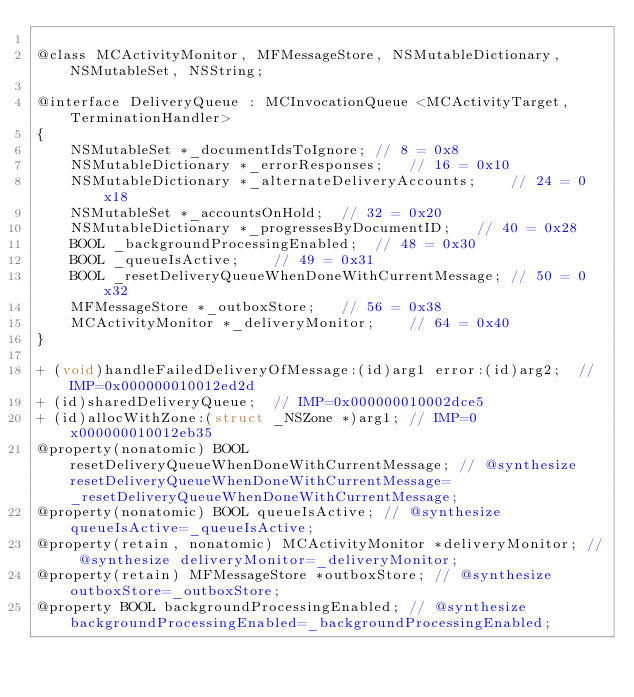Convert code to text. <code><loc_0><loc_0><loc_500><loc_500><_C_>
@class MCActivityMonitor, MFMessageStore, NSMutableDictionary, NSMutableSet, NSString;

@interface DeliveryQueue : MCInvocationQueue <MCActivityTarget, TerminationHandler>
{
    NSMutableSet *_documentIdsToIgnore;	// 8 = 0x8
    NSMutableDictionary *_errorResponses;	// 16 = 0x10
    NSMutableDictionary *_alternateDeliveryAccounts;	// 24 = 0x18
    NSMutableSet *_accountsOnHold;	// 32 = 0x20
    NSMutableDictionary *_progressesByDocumentID;	// 40 = 0x28
    BOOL _backgroundProcessingEnabled;	// 48 = 0x30
    BOOL _queueIsActive;	// 49 = 0x31
    BOOL _resetDeliveryQueueWhenDoneWithCurrentMessage;	// 50 = 0x32
    MFMessageStore *_outboxStore;	// 56 = 0x38
    MCActivityMonitor *_deliveryMonitor;	// 64 = 0x40
}

+ (void)handleFailedDeliveryOfMessage:(id)arg1 error:(id)arg2;	// IMP=0x000000010012ed2d
+ (id)sharedDeliveryQueue;	// IMP=0x000000010002dce5
+ (id)allocWithZone:(struct _NSZone *)arg1;	// IMP=0x000000010012eb35
@property(nonatomic) BOOL resetDeliveryQueueWhenDoneWithCurrentMessage; // @synthesize resetDeliveryQueueWhenDoneWithCurrentMessage=_resetDeliveryQueueWhenDoneWithCurrentMessage;
@property(nonatomic) BOOL queueIsActive; // @synthesize queueIsActive=_queueIsActive;
@property(retain, nonatomic) MCActivityMonitor *deliveryMonitor; // @synthesize deliveryMonitor=_deliveryMonitor;
@property(retain) MFMessageStore *outboxStore; // @synthesize outboxStore=_outboxStore;
@property BOOL backgroundProcessingEnabled; // @synthesize backgroundProcessingEnabled=_backgroundProcessingEnabled;</code> 